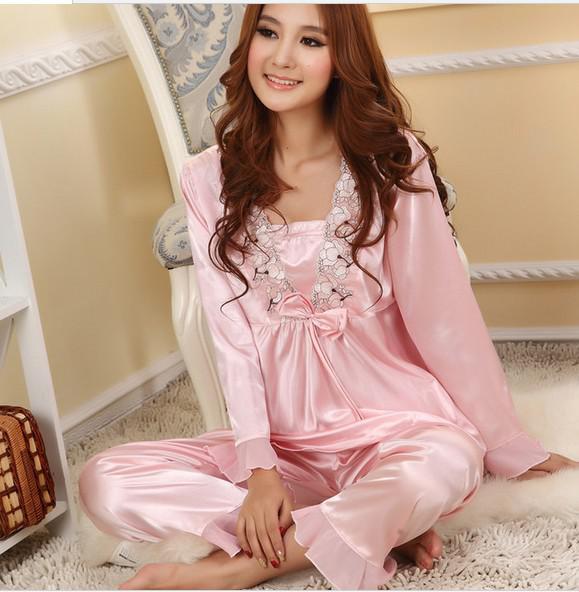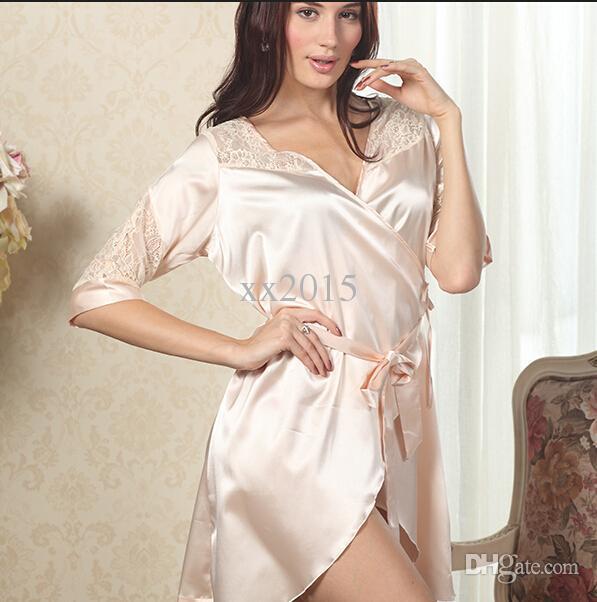The first image is the image on the left, the second image is the image on the right. Given the left and right images, does the statement "In one image, a woman in lingerie is standing; and in the other image, a woman in lingerie is seated and smiling." hold true? Answer yes or no. Yes. 